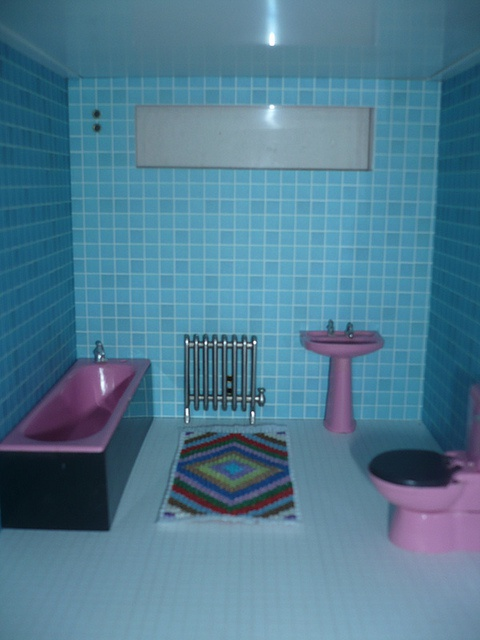Describe the objects in this image and their specific colors. I can see toilet in blue, violet, black, and purple tones and sink in blue, purple, and gray tones in this image. 